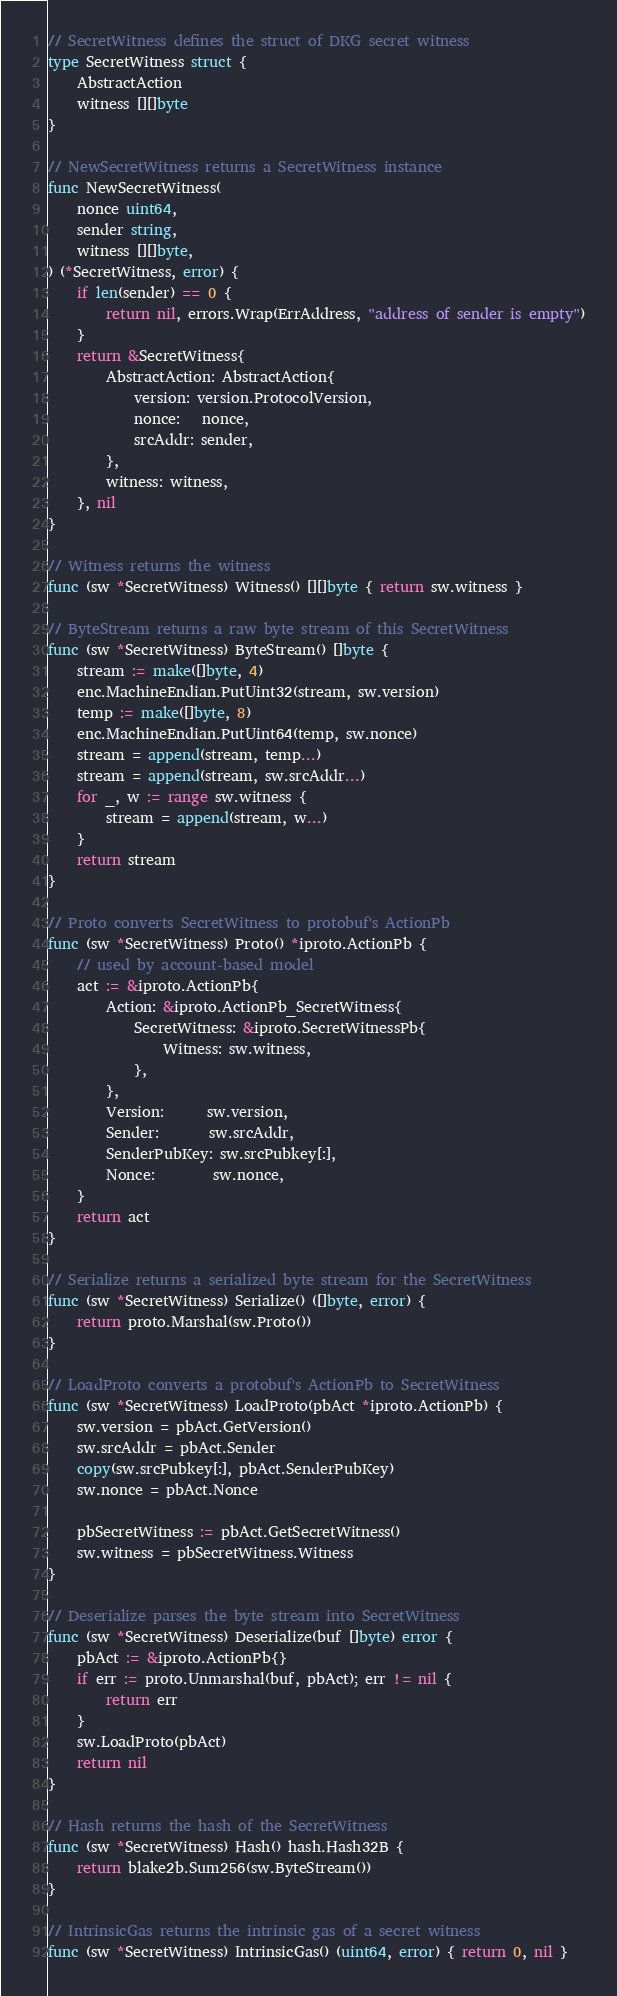<code> <loc_0><loc_0><loc_500><loc_500><_Go_>
// SecretWitness defines the struct of DKG secret witness
type SecretWitness struct {
	AbstractAction
	witness [][]byte
}

// NewSecretWitness returns a SecretWitness instance
func NewSecretWitness(
	nonce uint64,
	sender string,
	witness [][]byte,
) (*SecretWitness, error) {
	if len(sender) == 0 {
		return nil, errors.Wrap(ErrAddress, "address of sender is empty")
	}
	return &SecretWitness{
		AbstractAction: AbstractAction{
			version: version.ProtocolVersion,
			nonce:   nonce,
			srcAddr: sender,
		},
		witness: witness,
	}, nil
}

// Witness returns the witness
func (sw *SecretWitness) Witness() [][]byte { return sw.witness }

// ByteStream returns a raw byte stream of this SecretWitness
func (sw *SecretWitness) ByteStream() []byte {
	stream := make([]byte, 4)
	enc.MachineEndian.PutUint32(stream, sw.version)
	temp := make([]byte, 8)
	enc.MachineEndian.PutUint64(temp, sw.nonce)
	stream = append(stream, temp...)
	stream = append(stream, sw.srcAddr...)
	for _, w := range sw.witness {
		stream = append(stream, w...)
	}
	return stream
}

// Proto converts SecretWitness to protobuf's ActionPb
func (sw *SecretWitness) Proto() *iproto.ActionPb {
	// used by account-based model
	act := &iproto.ActionPb{
		Action: &iproto.ActionPb_SecretWitness{
			SecretWitness: &iproto.SecretWitnessPb{
				Witness: sw.witness,
			},
		},
		Version:      sw.version,
		Sender:       sw.srcAddr,
		SenderPubKey: sw.srcPubkey[:],
		Nonce:        sw.nonce,
	}
	return act
}

// Serialize returns a serialized byte stream for the SecretWitness
func (sw *SecretWitness) Serialize() ([]byte, error) {
	return proto.Marshal(sw.Proto())
}

// LoadProto converts a protobuf's ActionPb to SecretWitness
func (sw *SecretWitness) LoadProto(pbAct *iproto.ActionPb) {
	sw.version = pbAct.GetVersion()
	sw.srcAddr = pbAct.Sender
	copy(sw.srcPubkey[:], pbAct.SenderPubKey)
	sw.nonce = pbAct.Nonce

	pbSecretWitness := pbAct.GetSecretWitness()
	sw.witness = pbSecretWitness.Witness
}

// Deserialize parses the byte stream into SecretWitness
func (sw *SecretWitness) Deserialize(buf []byte) error {
	pbAct := &iproto.ActionPb{}
	if err := proto.Unmarshal(buf, pbAct); err != nil {
		return err
	}
	sw.LoadProto(pbAct)
	return nil
}

// Hash returns the hash of the SecretWitness
func (sw *SecretWitness) Hash() hash.Hash32B {
	return blake2b.Sum256(sw.ByteStream())
}

// IntrinsicGas returns the intrinsic gas of a secret witness
func (sw *SecretWitness) IntrinsicGas() (uint64, error) { return 0, nil }
</code> 